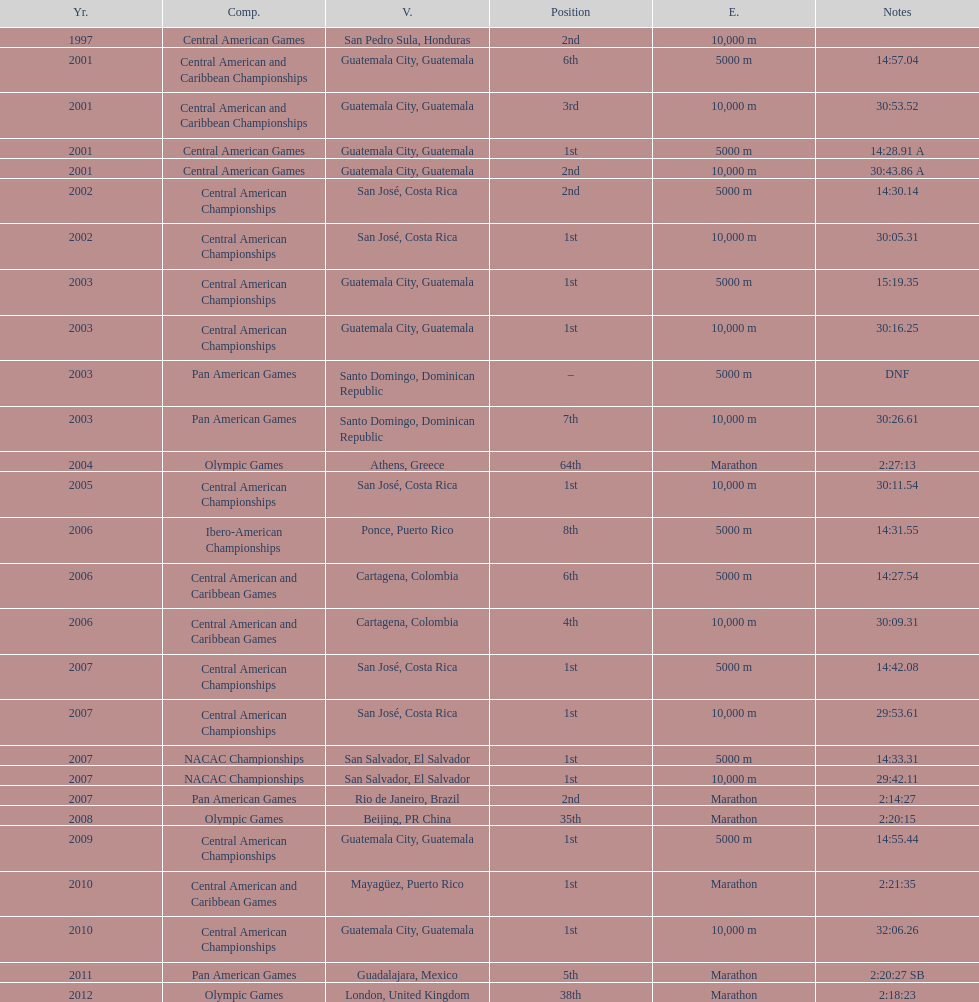What was the last competition in which a position of "2nd" was achieved? Pan American Games. 